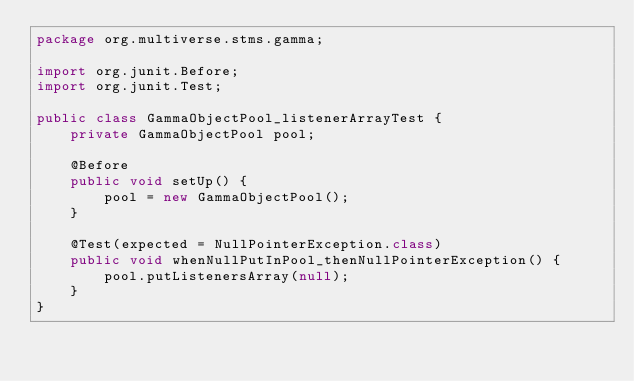<code> <loc_0><loc_0><loc_500><loc_500><_Java_>package org.multiverse.stms.gamma;

import org.junit.Before;
import org.junit.Test;

public class GammaObjectPool_listenerArrayTest {
    private GammaObjectPool pool;

    @Before
    public void setUp() {
        pool = new GammaObjectPool();
    }

    @Test(expected = NullPointerException.class)
    public void whenNullPutInPool_thenNullPointerException() {
        pool.putListenersArray(null);
    }
}
</code> 